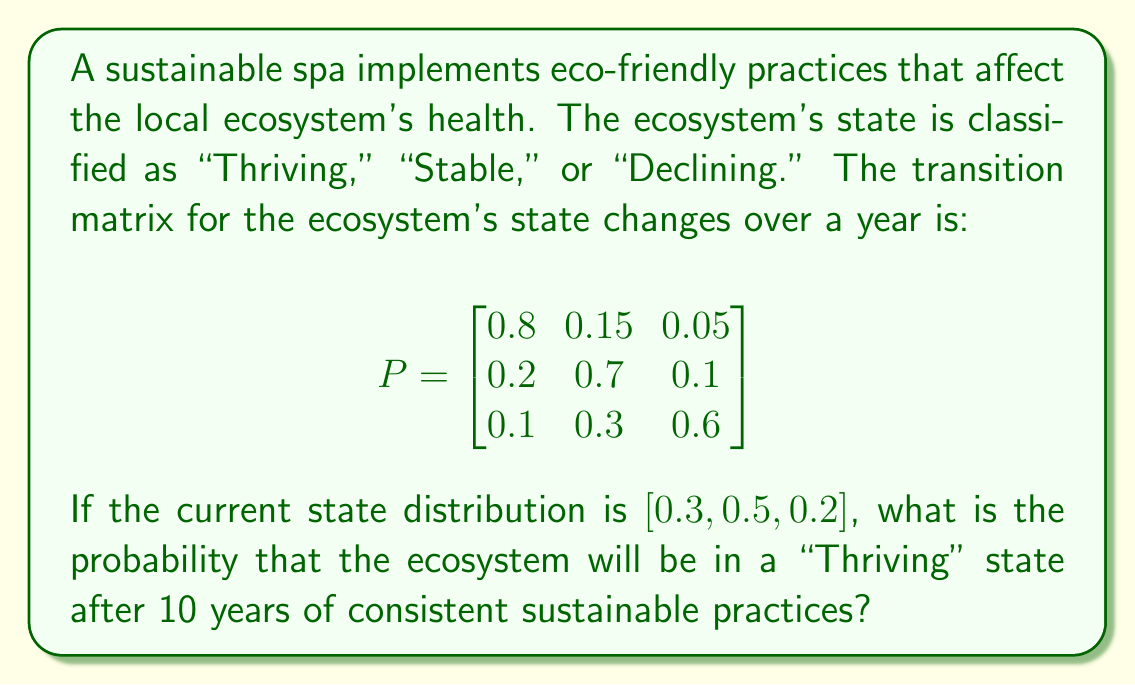Could you help me with this problem? To solve this problem, we'll use the properties of Markov chains:

1. Let's denote the initial state distribution as $\pi_0 = [0.3, 0.5, 0.2]$.

2. We need to find $\pi_{10} = \pi_0 \cdot P^{10}$, where $P^{10}$ is the transition matrix raised to the power of 10.

3. To calculate $P^{10}$, we can use the eigendecomposition method:
   
   a. Find the eigenvalues and eigenvectors of $P$.
   b. Form the diagonal matrix $D$ of eigenvalues and the matrix $V$ of eigenvectors.
   c. Calculate $P^{10} = V \cdot D^{10} \cdot V^{-1}$

4. Using a computer algebra system, we find:

   $$P^{10} \approx \begin{bmatrix}
   0.5714 & 0.2857 & 0.1429 \\
   0.5714 & 0.2857 & 0.1429 \\
   0.5714 & 0.2857 & 0.1429
   \end{bmatrix}$$

5. Now, we can calculate $\pi_{10}$:

   $$\pi_{10} = [0.3, 0.5, 0.2] \cdot \begin{bmatrix}
   0.5714 & 0.2857 & 0.1429 \\
   0.5714 & 0.2857 & 0.1429 \\
   0.5714 & 0.2857 & 0.1429
   \end{bmatrix}$$

   $$\pi_{10} = [0.5714, 0.2857, 0.1429]$$

6. The probability of the ecosystem being in a "Thriving" state after 10 years is the first element of $\pi_{10}$, which is approximately 0.5714 or 57.14%.
Answer: 0.5714 (or 57.14%) 